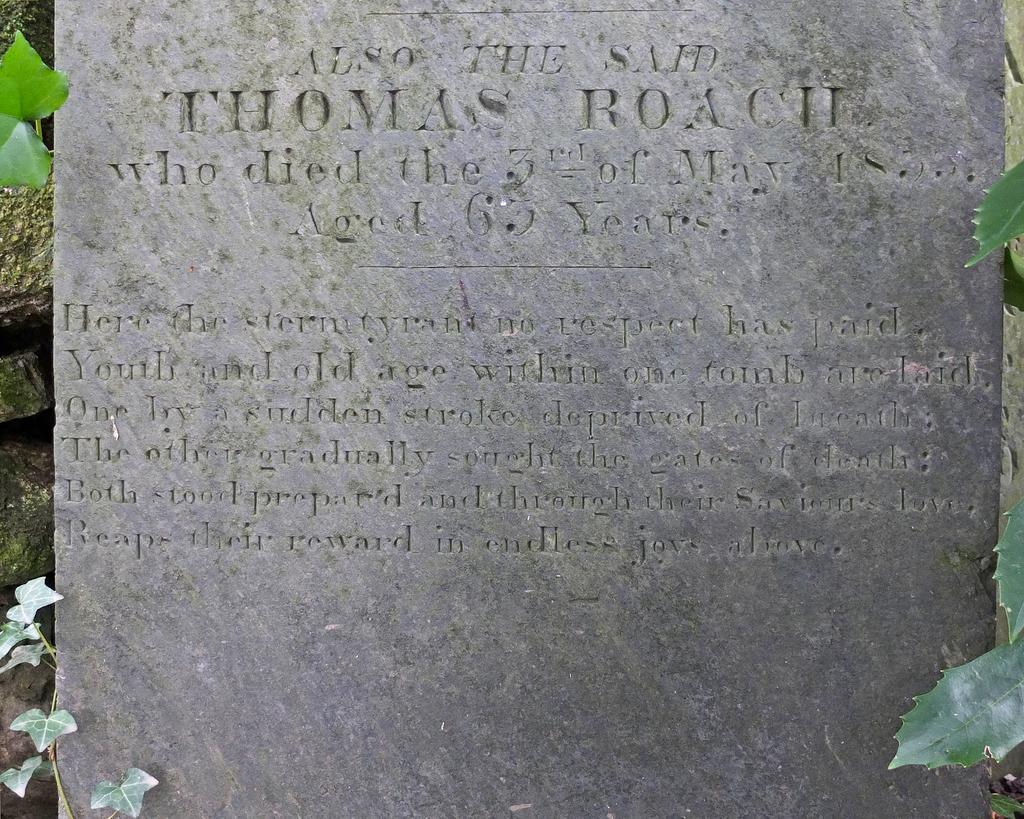Can you describe this image briefly? Something written on this rock wall. Here we can see green leaves. 